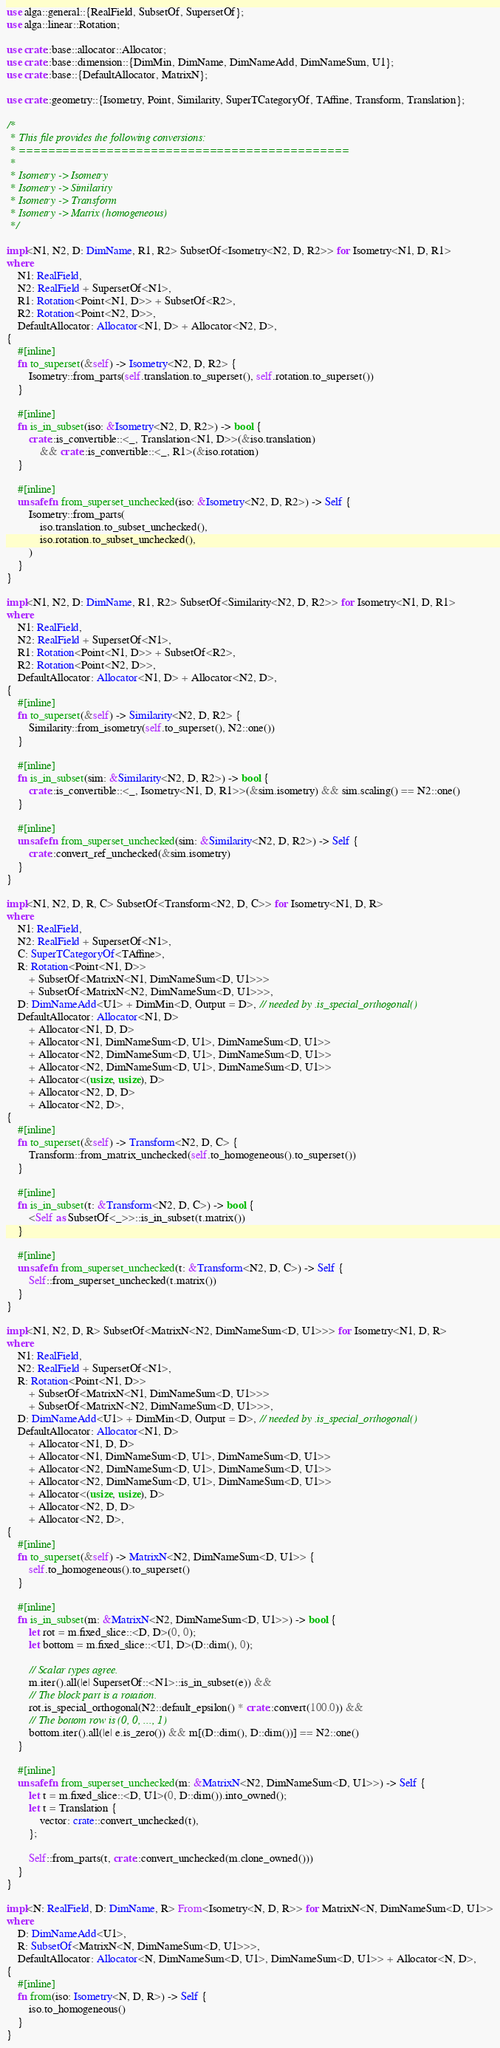<code> <loc_0><loc_0><loc_500><loc_500><_Rust_>use alga::general::{RealField, SubsetOf, SupersetOf};
use alga::linear::Rotation;

use crate::base::allocator::Allocator;
use crate::base::dimension::{DimMin, DimName, DimNameAdd, DimNameSum, U1};
use crate::base::{DefaultAllocator, MatrixN};

use crate::geometry::{Isometry, Point, Similarity, SuperTCategoryOf, TAffine, Transform, Translation};

/*
 * This file provides the following conversions:
 * =============================================
 *
 * Isometry -> Isometry
 * Isometry -> Similarity
 * Isometry -> Transform
 * Isometry -> Matrix (homogeneous)
 */

impl<N1, N2, D: DimName, R1, R2> SubsetOf<Isometry<N2, D, R2>> for Isometry<N1, D, R1>
where
    N1: RealField,
    N2: RealField + SupersetOf<N1>,
    R1: Rotation<Point<N1, D>> + SubsetOf<R2>,
    R2: Rotation<Point<N2, D>>,
    DefaultAllocator: Allocator<N1, D> + Allocator<N2, D>,
{
    #[inline]
    fn to_superset(&self) -> Isometry<N2, D, R2> {
        Isometry::from_parts(self.translation.to_superset(), self.rotation.to_superset())
    }

    #[inline]
    fn is_in_subset(iso: &Isometry<N2, D, R2>) -> bool {
        crate::is_convertible::<_, Translation<N1, D>>(&iso.translation)
            && crate::is_convertible::<_, R1>(&iso.rotation)
    }

    #[inline]
    unsafe fn from_superset_unchecked(iso: &Isometry<N2, D, R2>) -> Self {
        Isometry::from_parts(
            iso.translation.to_subset_unchecked(),
            iso.rotation.to_subset_unchecked(),
        )
    }
}

impl<N1, N2, D: DimName, R1, R2> SubsetOf<Similarity<N2, D, R2>> for Isometry<N1, D, R1>
where
    N1: RealField,
    N2: RealField + SupersetOf<N1>,
    R1: Rotation<Point<N1, D>> + SubsetOf<R2>,
    R2: Rotation<Point<N2, D>>,
    DefaultAllocator: Allocator<N1, D> + Allocator<N2, D>,
{
    #[inline]
    fn to_superset(&self) -> Similarity<N2, D, R2> {
        Similarity::from_isometry(self.to_superset(), N2::one())
    }

    #[inline]
    fn is_in_subset(sim: &Similarity<N2, D, R2>) -> bool {
        crate::is_convertible::<_, Isometry<N1, D, R1>>(&sim.isometry) && sim.scaling() == N2::one()
    }

    #[inline]
    unsafe fn from_superset_unchecked(sim: &Similarity<N2, D, R2>) -> Self {
        crate::convert_ref_unchecked(&sim.isometry)
    }
}

impl<N1, N2, D, R, C> SubsetOf<Transform<N2, D, C>> for Isometry<N1, D, R>
where
    N1: RealField,
    N2: RealField + SupersetOf<N1>,
    C: SuperTCategoryOf<TAffine>,
    R: Rotation<Point<N1, D>>
        + SubsetOf<MatrixN<N1, DimNameSum<D, U1>>>
        + SubsetOf<MatrixN<N2, DimNameSum<D, U1>>>,
    D: DimNameAdd<U1> + DimMin<D, Output = D>, // needed by .is_special_orthogonal()
    DefaultAllocator: Allocator<N1, D>
        + Allocator<N1, D, D>
        + Allocator<N1, DimNameSum<D, U1>, DimNameSum<D, U1>>
        + Allocator<N2, DimNameSum<D, U1>, DimNameSum<D, U1>>
        + Allocator<N2, DimNameSum<D, U1>, DimNameSum<D, U1>>
        + Allocator<(usize, usize), D>
        + Allocator<N2, D, D>
        + Allocator<N2, D>,
{
    #[inline]
    fn to_superset(&self) -> Transform<N2, D, C> {
        Transform::from_matrix_unchecked(self.to_homogeneous().to_superset())
    }

    #[inline]
    fn is_in_subset(t: &Transform<N2, D, C>) -> bool {
        <Self as SubsetOf<_>>::is_in_subset(t.matrix())
    }

    #[inline]
    unsafe fn from_superset_unchecked(t: &Transform<N2, D, C>) -> Self {
        Self::from_superset_unchecked(t.matrix())
    }
}

impl<N1, N2, D, R> SubsetOf<MatrixN<N2, DimNameSum<D, U1>>> for Isometry<N1, D, R>
where
    N1: RealField,
    N2: RealField + SupersetOf<N1>,
    R: Rotation<Point<N1, D>>
        + SubsetOf<MatrixN<N1, DimNameSum<D, U1>>>
        + SubsetOf<MatrixN<N2, DimNameSum<D, U1>>>,
    D: DimNameAdd<U1> + DimMin<D, Output = D>, // needed by .is_special_orthogonal()
    DefaultAllocator: Allocator<N1, D>
        + Allocator<N1, D, D>
        + Allocator<N1, DimNameSum<D, U1>, DimNameSum<D, U1>>
        + Allocator<N2, DimNameSum<D, U1>, DimNameSum<D, U1>>
        + Allocator<N2, DimNameSum<D, U1>, DimNameSum<D, U1>>
        + Allocator<(usize, usize), D>
        + Allocator<N2, D, D>
        + Allocator<N2, D>,
{
    #[inline]
    fn to_superset(&self) -> MatrixN<N2, DimNameSum<D, U1>> {
        self.to_homogeneous().to_superset()
    }

    #[inline]
    fn is_in_subset(m: &MatrixN<N2, DimNameSum<D, U1>>) -> bool {
        let rot = m.fixed_slice::<D, D>(0, 0);
        let bottom = m.fixed_slice::<U1, D>(D::dim(), 0);

        // Scalar types agree.
        m.iter().all(|e| SupersetOf::<N1>::is_in_subset(e)) &&
        // The block part is a rotation.
        rot.is_special_orthogonal(N2::default_epsilon() * crate::convert(100.0)) &&
        // The bottom row is (0, 0, ..., 1)
        bottom.iter().all(|e| e.is_zero()) && m[(D::dim(), D::dim())] == N2::one()
    }

    #[inline]
    unsafe fn from_superset_unchecked(m: &MatrixN<N2, DimNameSum<D, U1>>) -> Self {
        let t = m.fixed_slice::<D, U1>(0, D::dim()).into_owned();
        let t = Translation {
            vector: crate::convert_unchecked(t),
        };

        Self::from_parts(t, crate::convert_unchecked(m.clone_owned()))
    }
}

impl<N: RealField, D: DimName, R> From<Isometry<N, D, R>> for MatrixN<N, DimNameSum<D, U1>>
where
    D: DimNameAdd<U1>,
    R: SubsetOf<MatrixN<N, DimNameSum<D, U1>>>,
    DefaultAllocator: Allocator<N, DimNameSum<D, U1>, DimNameSum<D, U1>> + Allocator<N, D>,
{
    #[inline]
    fn from(iso: Isometry<N, D, R>) -> Self {
        iso.to_homogeneous()
    }
}
</code> 